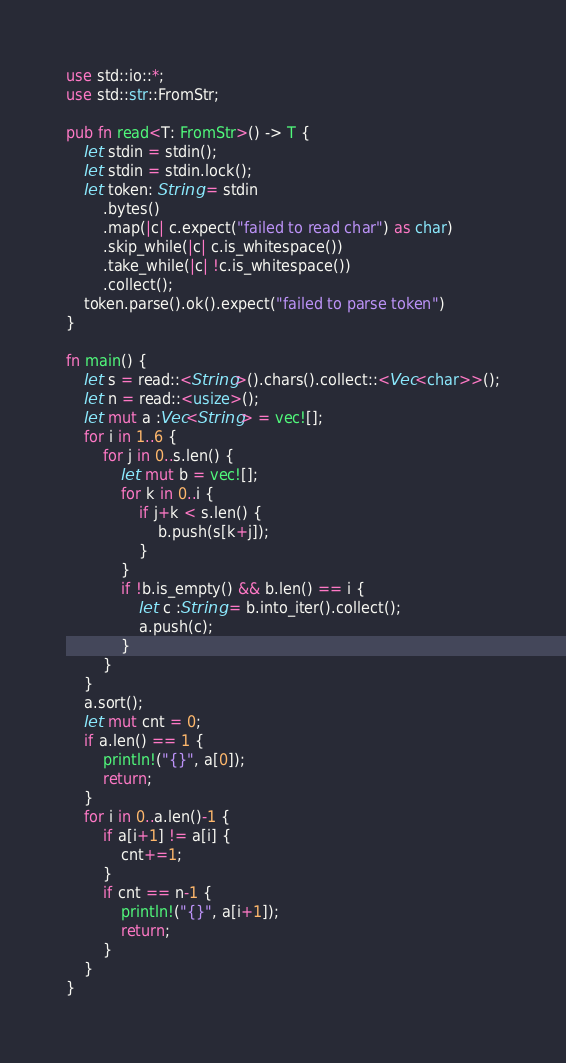<code> <loc_0><loc_0><loc_500><loc_500><_Rust_>use std::io::*;
use std::str::FromStr;

pub fn read<T: FromStr>() -> T {
    let stdin = stdin();
    let stdin = stdin.lock();
    let token: String = stdin
        .bytes()
        .map(|c| c.expect("failed to read char") as char)
        .skip_while(|c| c.is_whitespace())
        .take_while(|c| !c.is_whitespace())
        .collect();
    token.parse().ok().expect("failed to parse token")
}

fn main() {
    let s = read::<String>().chars().collect::<Vec<char>>();
    let n = read::<usize>();
    let mut a :Vec<String> = vec![];
    for i in 1..6 {
        for j in 0..s.len() {
            let mut b = vec![];
            for k in 0..i {
                if j+k < s.len() {
                    b.push(s[k+j]);
                }
            }
            if !b.is_empty() && b.len() == i {
                let c :String = b.into_iter().collect();
                a.push(c);
            }
        }
    }
    a.sort();
    let mut cnt = 0;
    if a.len() == 1 {
        println!("{}", a[0]);
        return;
    }
    for i in 0..a.len()-1 {
        if a[i+1] != a[i] {
            cnt+=1;
        }
        if cnt == n-1 {
            println!("{}", a[i+1]);
            return;
        }
    }
}</code> 